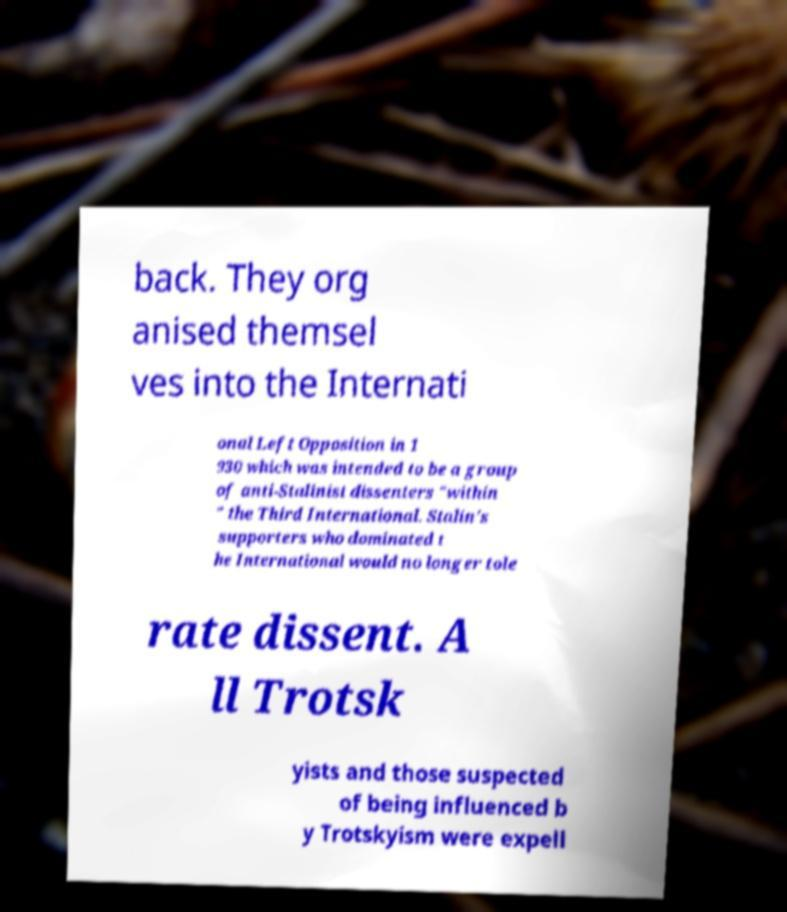What messages or text are displayed in this image? I need them in a readable, typed format. back. They org anised themsel ves into the Internati onal Left Opposition in 1 930 which was intended to be a group of anti-Stalinist dissenters "within " the Third International. Stalin's supporters who dominated t he International would no longer tole rate dissent. A ll Trotsk yists and those suspected of being influenced b y Trotskyism were expell 